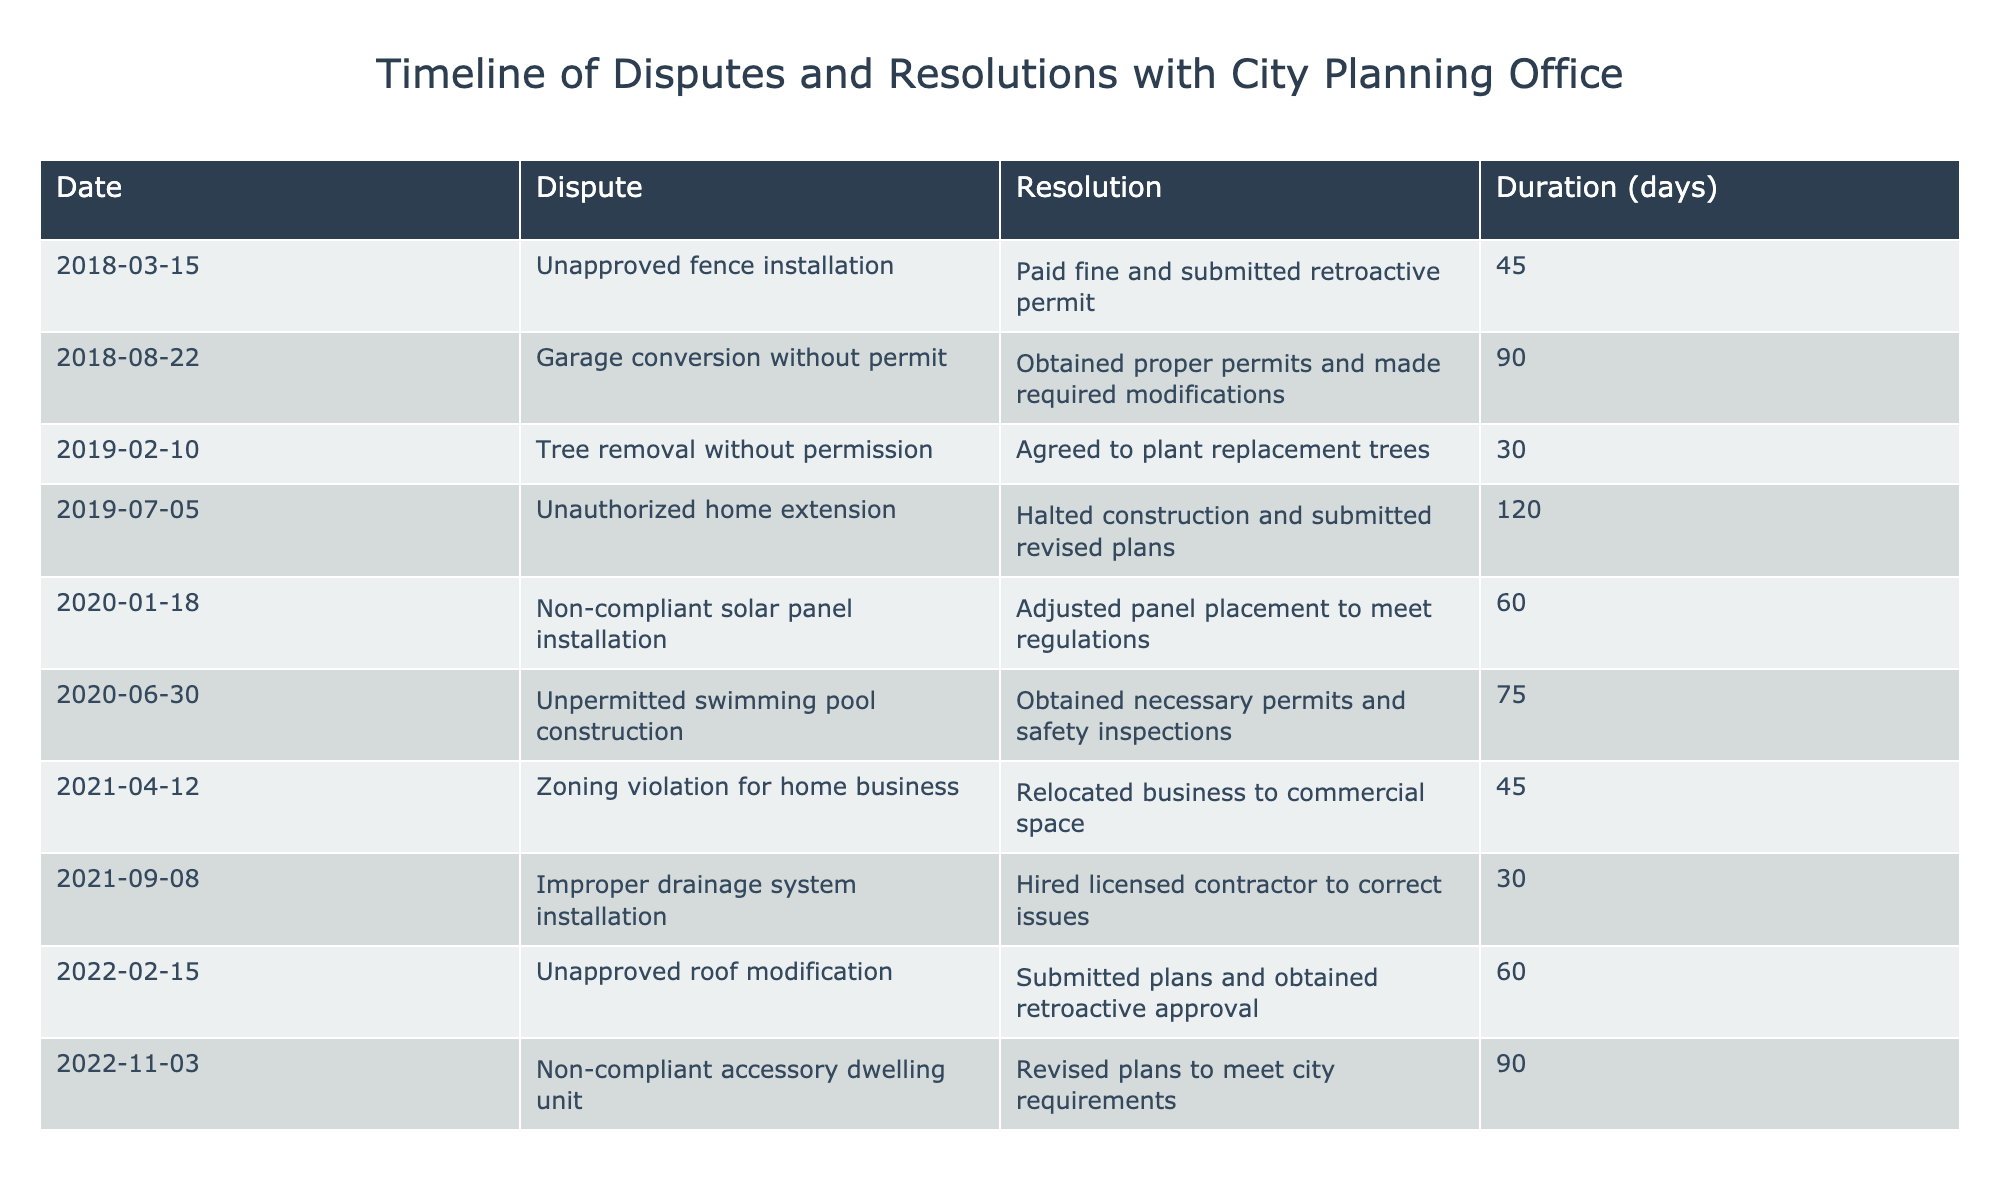What is the resolution for the unapproved fence installation dispute? The table states that for the unapproved fence installation dispute, the resolution was to pay a fine and submit a retroactive permit.
Answer: Paid fine and submitted retroactive permit How many days did it take to resolve the garage conversion dispute? The table indicates that the duration for the garage conversion dispute resolution was 90 days.
Answer: 90 days What dispute had the shortest duration to resolve? The table shows that the shortest duration was for the tree removal dispute, which took 30 days to resolve.
Answer: 30 days Is there a dispute related to solar panel installation? Yes, the table includes a dispute about non-compliant solar panel installation.
Answer: Yes What was the most common type of resolution for these disputes? By analyzing the table, one can see that "obtained proper permits" or variations of this resolution appear most frequently.
Answer: Obtained proper permits If I compare the duration of the most recent dispute with the oldest dispute, which was longer? The most recent dispute (non-compliant accessory dwelling unit) took 90 days, while the oldest dispute (unapproved fence installation) took 45 days. Therefore, the most recent dispute was longer.
Answer: Most recent dispute was longer What is the average duration of all disputes listed in the table? To find the average, sum the durations (45 + 90 + 30 + 120 + 60 + 75 + 45 + 30 + 60 + 90 = 600) and divide by the total number of disputes (10). Thus, 600/10 = 60 days on average.
Answer: 60 days How many disputes involved the requirement to submit revised plans? The table shows that there are two disputes that required submission of revised plans: the uncontrolled home extension and the non-compliant accessory dwelling unit.
Answer: 2 disputes What discrepancy exists between disputes that were resolved by hiring contractors and those resolved by obtaining permits? The table shows that two disputes were resolved by hiring contractors (improper drainage system installation) while five disputes were resolved by obtaining permits or submitting plans for approval.
Answer: 2 vs 5 Which dispute took the longest to resolve and how many days did it take? The unauthorized home extension dispute took the longest to resolve at 120 days.
Answer: 120 days 